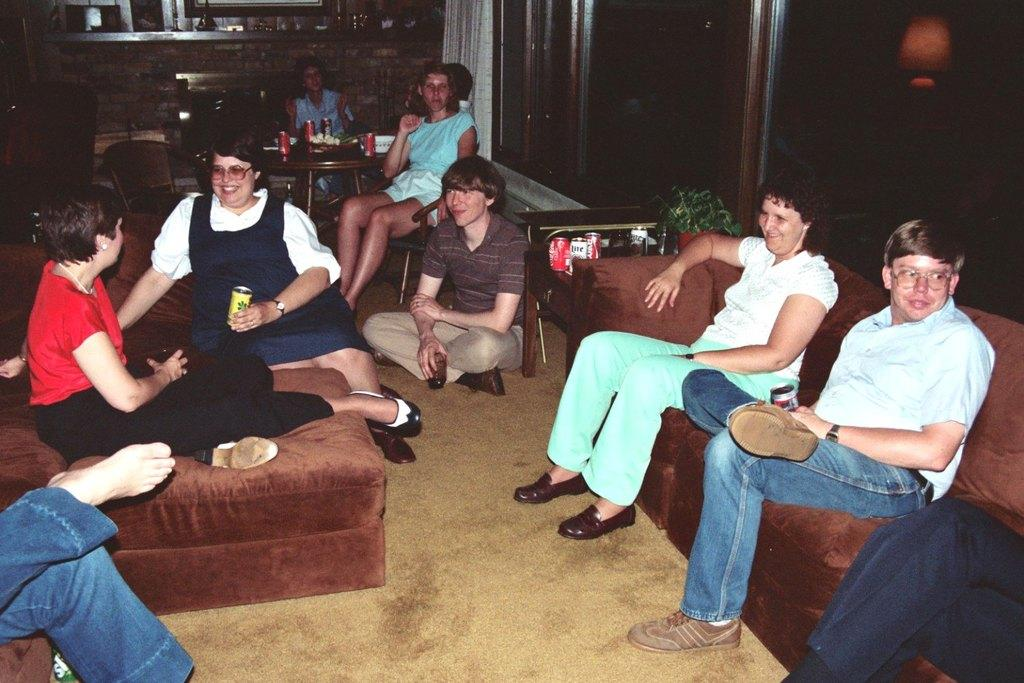Who is present in the image? There are people in the image. How are the people positioned in the image? The people are seated on chairs and on the floor. What expressions do the people have in the image? The people have smiles on their faces. What are the people holding in their hands? The people are holding drinks in their hands. What type of soup is being served in the image? There is no soup present in the image; the people are holding drinks. Can you see a cat in the image? There is no cat present in the image. 